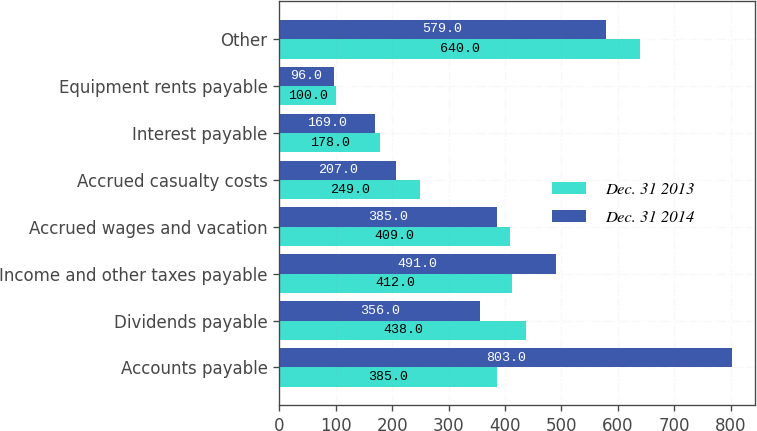Convert chart to OTSL. <chart><loc_0><loc_0><loc_500><loc_500><stacked_bar_chart><ecel><fcel>Accounts payable<fcel>Dividends payable<fcel>Income and other taxes payable<fcel>Accrued wages and vacation<fcel>Accrued casualty costs<fcel>Interest payable<fcel>Equipment rents payable<fcel>Other<nl><fcel>Dec. 31 2013<fcel>385<fcel>438<fcel>412<fcel>409<fcel>249<fcel>178<fcel>100<fcel>640<nl><fcel>Dec. 31 2014<fcel>803<fcel>356<fcel>491<fcel>385<fcel>207<fcel>169<fcel>96<fcel>579<nl></chart> 